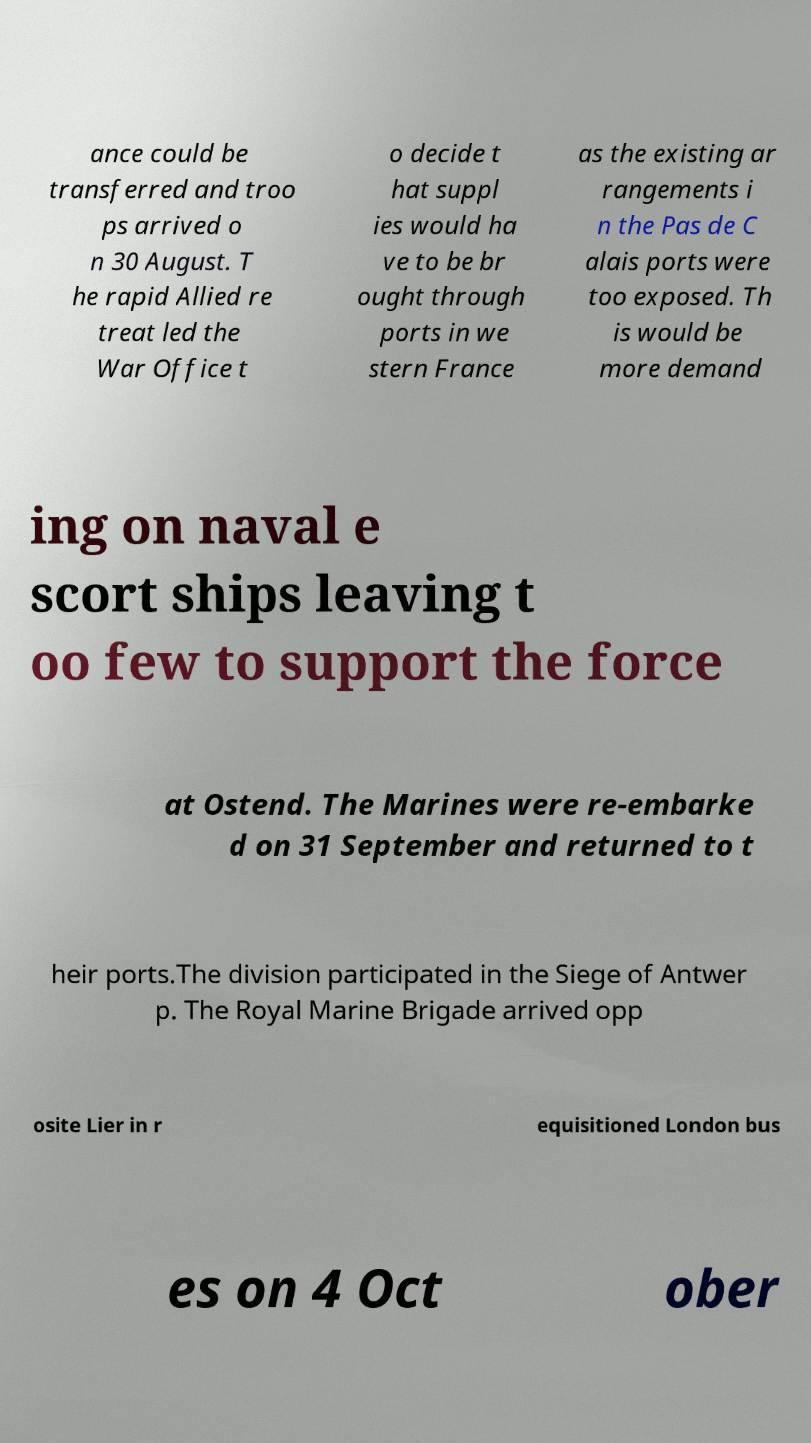Could you assist in decoding the text presented in this image and type it out clearly? ance could be transferred and troo ps arrived o n 30 August. T he rapid Allied re treat led the War Office t o decide t hat suppl ies would ha ve to be br ought through ports in we stern France as the existing ar rangements i n the Pas de C alais ports were too exposed. Th is would be more demand ing on naval e scort ships leaving t oo few to support the force at Ostend. The Marines were re-embarke d on 31 September and returned to t heir ports.The division participated in the Siege of Antwer p. The Royal Marine Brigade arrived opp osite Lier in r equisitioned London bus es on 4 Oct ober 